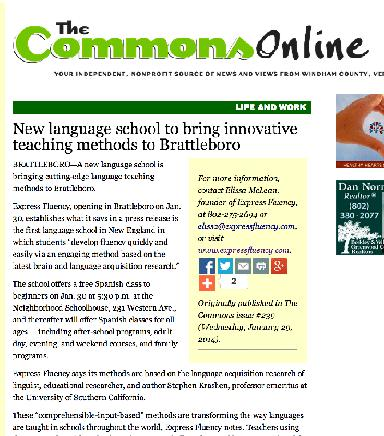What community impact do the founders hope to achieve with the new school? The founders aim to make language learning more accessible and engaging within the community, thereby fostering greater cultural awareness and communication skills among residents of all ages in Brattleboro. 